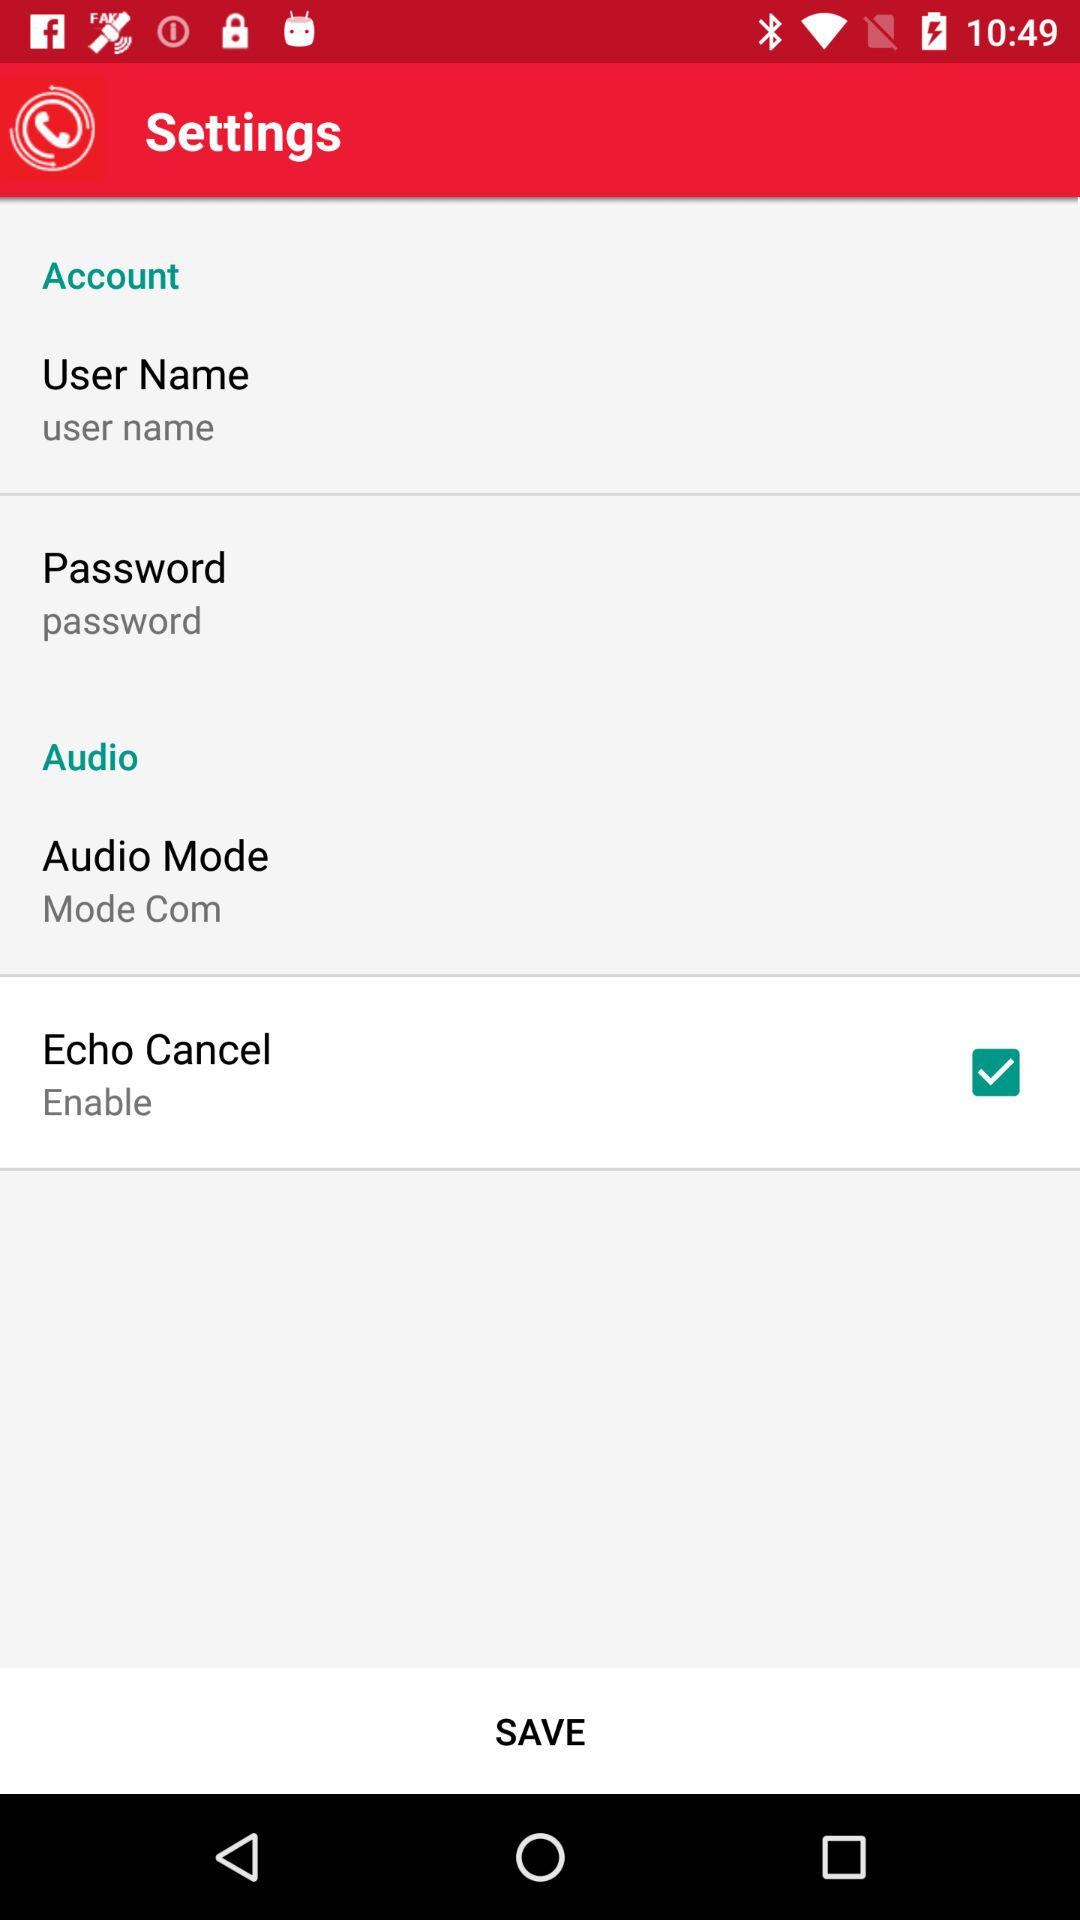Is the "Echo Cancel" setting enabled or disabled? The "Echo Cancel" setting is enabled. 